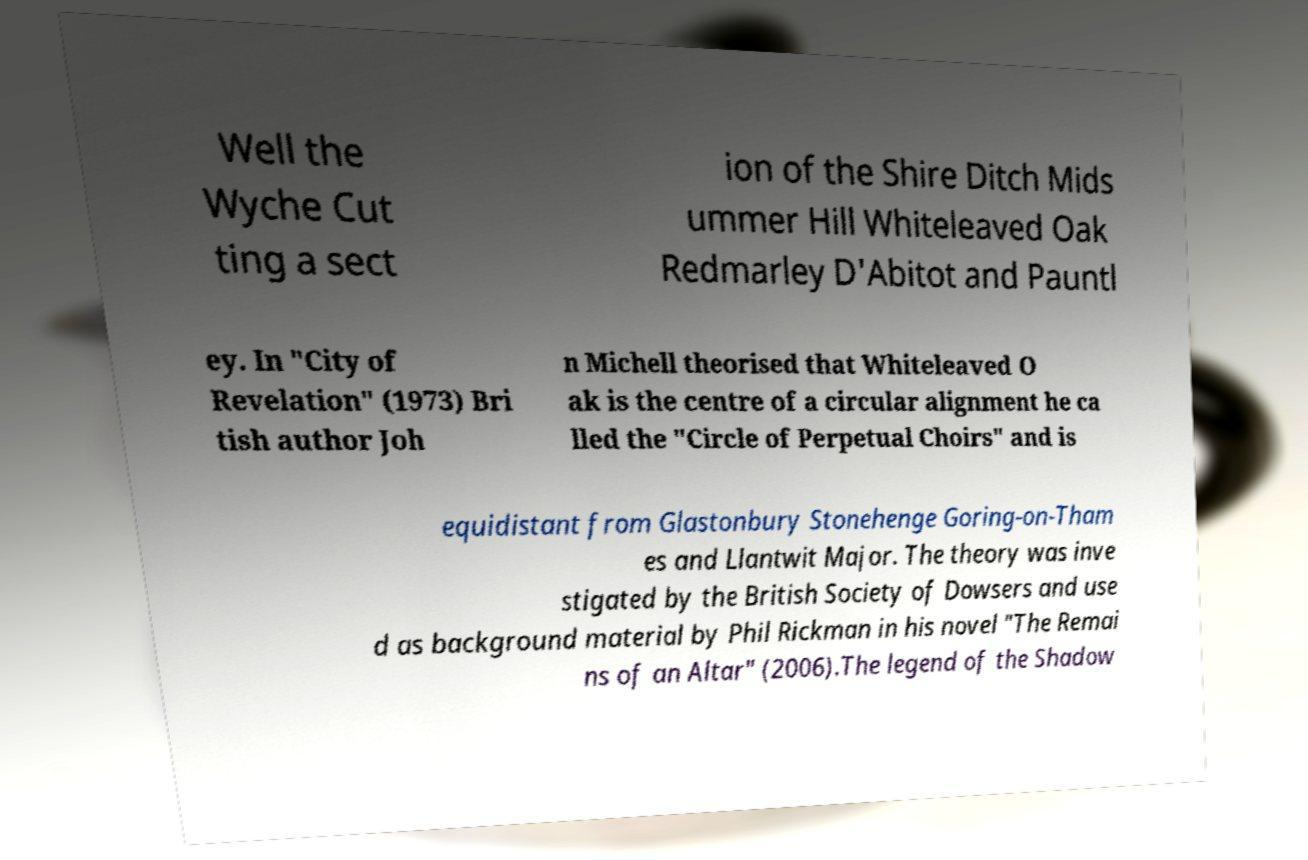Please identify and transcribe the text found in this image. Well the Wyche Cut ting a sect ion of the Shire Ditch Mids ummer Hill Whiteleaved Oak Redmarley D'Abitot and Pauntl ey. In "City of Revelation" (1973) Bri tish author Joh n Michell theorised that Whiteleaved O ak is the centre of a circular alignment he ca lled the "Circle of Perpetual Choirs" and is equidistant from Glastonbury Stonehenge Goring-on-Tham es and Llantwit Major. The theory was inve stigated by the British Society of Dowsers and use d as background material by Phil Rickman in his novel "The Remai ns of an Altar" (2006).The legend of the Shadow 